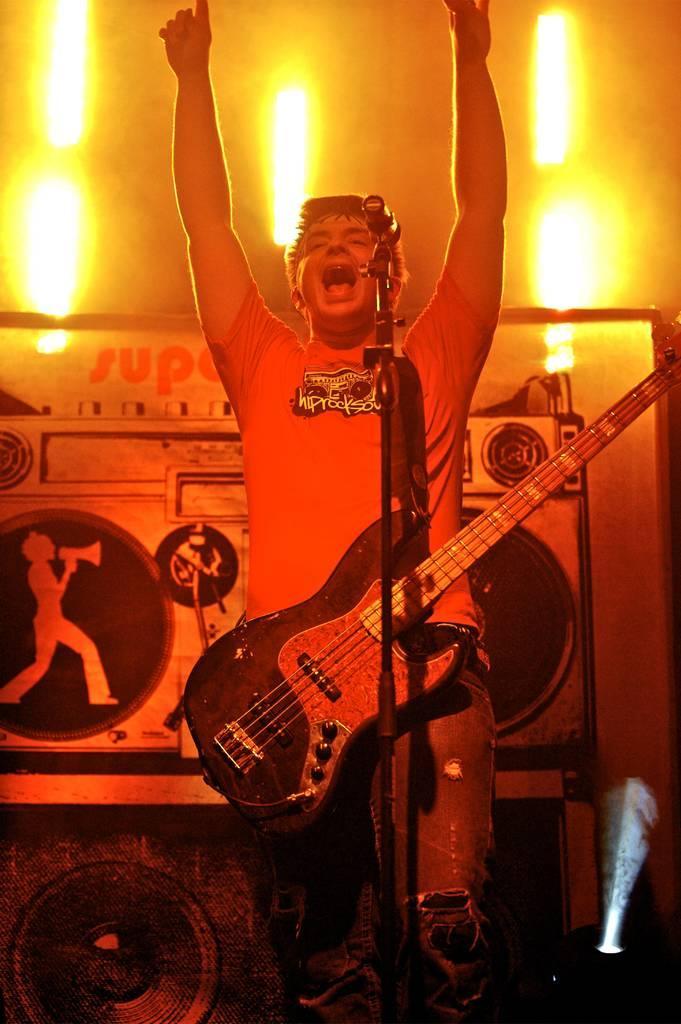Can you describe this image briefly? There is a man in the picture, holding a guitar across his shoulders. He is raising his two hands in the air. In front of him there is a microphone and a stand. He is singing. In the background, there are some lights and a poster here. 